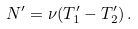Convert formula to latex. <formula><loc_0><loc_0><loc_500><loc_500>N ^ { \prime } = \nu ( T ^ { \prime } _ { 1 } - T ^ { \prime } _ { 2 } ) \, .</formula> 